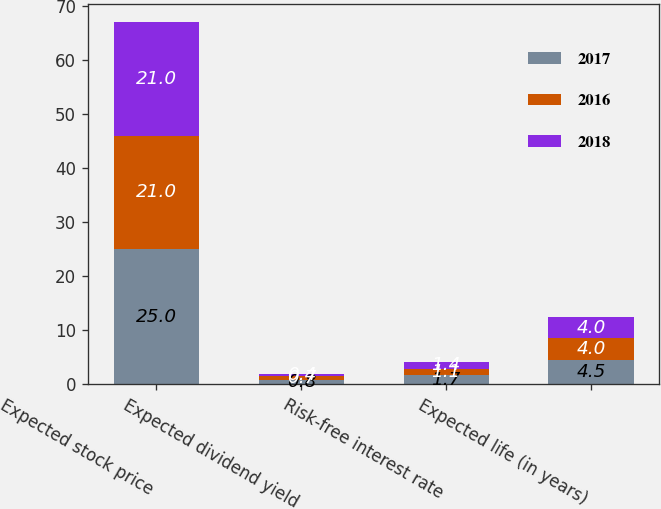Convert chart. <chart><loc_0><loc_0><loc_500><loc_500><stacked_bar_chart><ecel><fcel>Expected stock price<fcel>Expected dividend yield<fcel>Risk-free interest rate<fcel>Expected life (in years)<nl><fcel>2017<fcel>25<fcel>0.8<fcel>1.7<fcel>4.5<nl><fcel>2016<fcel>21<fcel>0.7<fcel>1.1<fcel>4<nl><fcel>2018<fcel>21<fcel>0.4<fcel>1.4<fcel>4<nl></chart> 